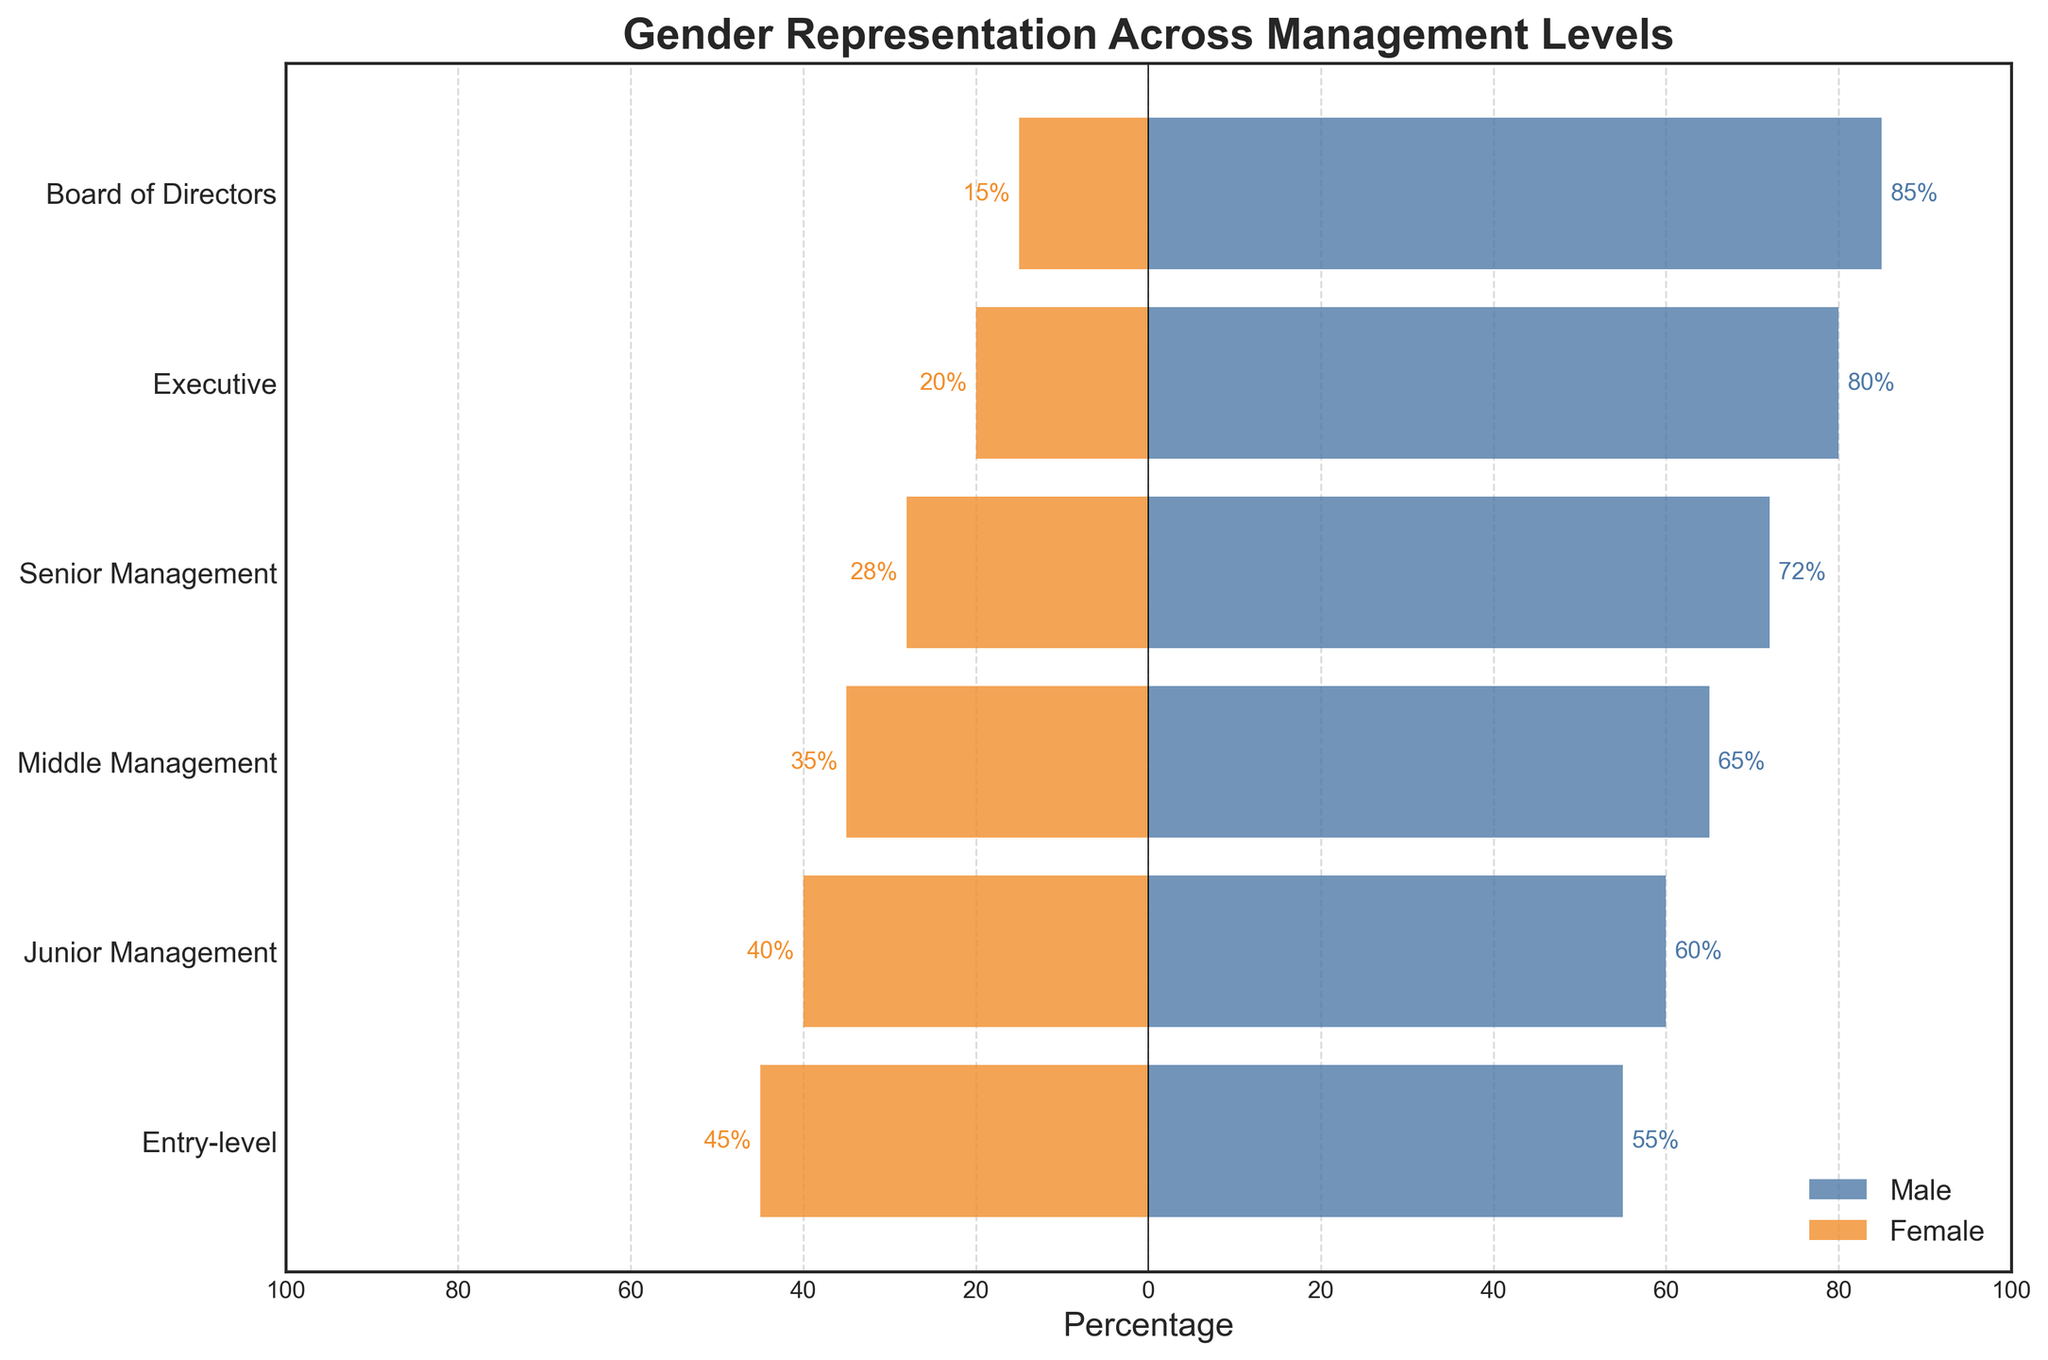What's the title of the figure? The title is usually located at the top of the figure. From the code, it's specified as 'Gender Representation Across Management Levels'.
Answer: Gender Representation Across Management Levels What is the percentage of males in Entry-level positions? From the male bar aligned to the Entry-level tick, the percentage is shown directly at the end of the bar.
Answer: 55% How does the representation of females change as you move up the management levels? Observing the negative bars from bottom to top, the percentage of females decreases as the level increases, starting from 45% in Entry-level to 15% in the Board of Directors.
Answer: Decreases Which management level shows the smallest gender gap? By comparing the lengths of the male and female bars at each level, the Entry-level positions have the smallest gap of 10% (55% Male, 45% Female).
Answer: Entry-level At which management level is the male representation the highest? Look for the longest positive bar. The Board of Directors level has the highest male representation at 85%.
Answer: Board of Directors What is the difference in female representation between Middle Management and Senior Management? Female representation in Middle Management is 35% and in Senior Management is 28%. The difference is found by subtracting the percentages: 35% - 28%.
Answer: 7% Is there any management level where the female representation is higher than the male representation? By comparing all levels, there is no level where the negative (female) bar is longer than the positive (male) bar.
Answer: No What overall trend do you observe in male representation across management levels? The positive bars show an increasing trend from Entry-level (55%) to Board of Directors (85%).
Answer: Increasing trend Calculate the average female representation across all management levels. Sum up the percentages of females at each level (45 + 40 + 35 + 28 + 20 + 15) and divide by the number of levels (6). This yields (183 / 6).
Answer: 30.5% Which two consecutive management levels exhibit the largest drop in female representation? By comparing consecutive levels, the largest drop is observed between Middle Management (35%) and Senior Management (28%), which is a drop of 7%.
Answer: Middle Management and Senior Management 